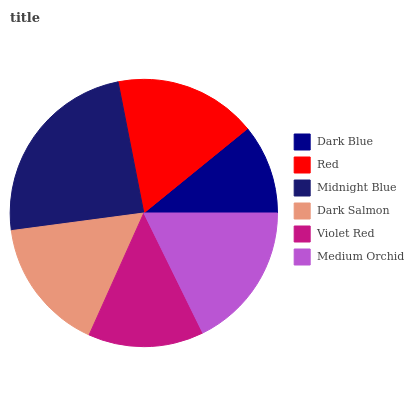Is Dark Blue the minimum?
Answer yes or no. Yes. Is Midnight Blue the maximum?
Answer yes or no. Yes. Is Red the minimum?
Answer yes or no. No. Is Red the maximum?
Answer yes or no. No. Is Red greater than Dark Blue?
Answer yes or no. Yes. Is Dark Blue less than Red?
Answer yes or no. Yes. Is Dark Blue greater than Red?
Answer yes or no. No. Is Red less than Dark Blue?
Answer yes or no. No. Is Red the high median?
Answer yes or no. Yes. Is Dark Salmon the low median?
Answer yes or no. Yes. Is Medium Orchid the high median?
Answer yes or no. No. Is Midnight Blue the low median?
Answer yes or no. No. 